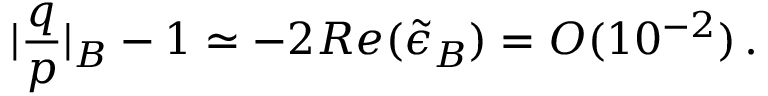Convert formula to latex. <formula><loc_0><loc_0><loc_500><loc_500>| \frac { q } { p } | _ { B } - 1 \simeq - 2 R e ( \tilde { \epsilon } _ { B } ) = O ( 1 0 ^ { - 2 } ) \, .</formula> 